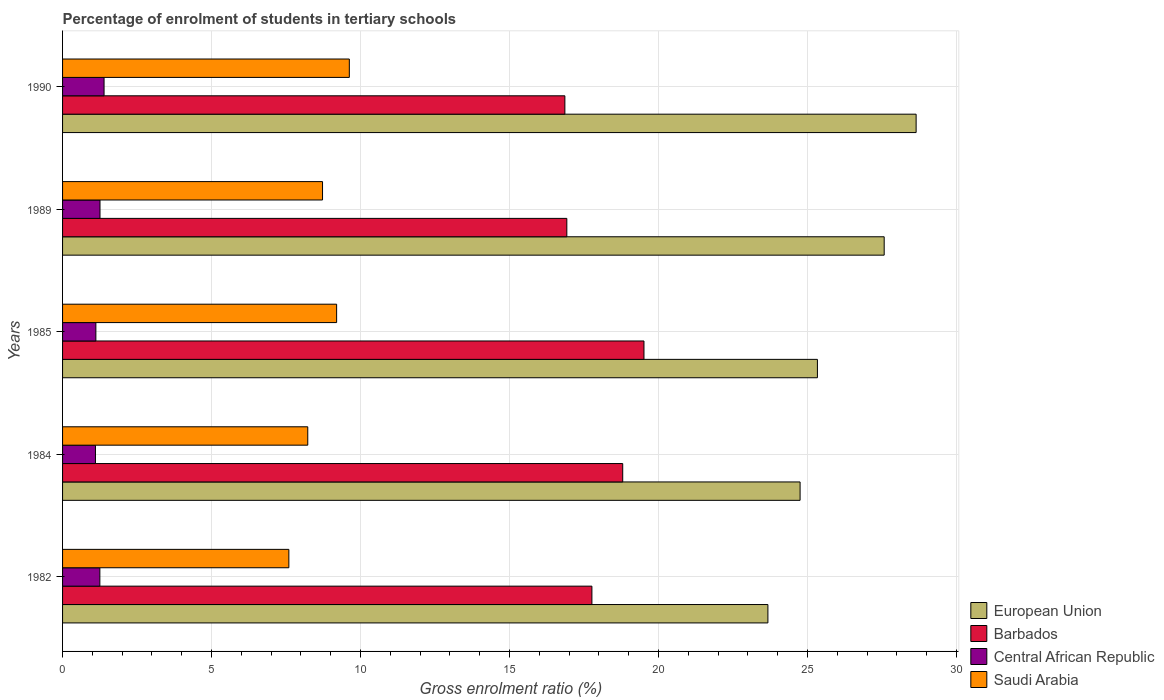How many different coloured bars are there?
Provide a short and direct response. 4. How many groups of bars are there?
Provide a short and direct response. 5. What is the label of the 3rd group of bars from the top?
Provide a short and direct response. 1985. In how many cases, is the number of bars for a given year not equal to the number of legend labels?
Provide a succinct answer. 0. What is the percentage of students enrolled in tertiary schools in Barbados in 1989?
Offer a terse response. 16.92. Across all years, what is the maximum percentage of students enrolled in tertiary schools in Central African Republic?
Your response must be concise. 1.39. Across all years, what is the minimum percentage of students enrolled in tertiary schools in Barbados?
Make the answer very short. 16.86. In which year was the percentage of students enrolled in tertiary schools in Barbados minimum?
Provide a short and direct response. 1990. What is the total percentage of students enrolled in tertiary schools in Barbados in the graph?
Your response must be concise. 89.85. What is the difference between the percentage of students enrolled in tertiary schools in Barbados in 1984 and that in 1990?
Your answer should be very brief. 1.94. What is the difference between the percentage of students enrolled in tertiary schools in Central African Republic in 1985 and the percentage of students enrolled in tertiary schools in Barbados in 1982?
Your response must be concise. -16.65. What is the average percentage of students enrolled in tertiary schools in Central African Republic per year?
Give a very brief answer. 1.22. In the year 1990, what is the difference between the percentage of students enrolled in tertiary schools in Central African Republic and percentage of students enrolled in tertiary schools in Barbados?
Offer a very short reply. -15.46. In how many years, is the percentage of students enrolled in tertiary schools in European Union greater than 20 %?
Provide a succinct answer. 5. What is the ratio of the percentage of students enrolled in tertiary schools in Saudi Arabia in 1984 to that in 1990?
Offer a very short reply. 0.86. Is the difference between the percentage of students enrolled in tertiary schools in Central African Republic in 1982 and 1989 greater than the difference between the percentage of students enrolled in tertiary schools in Barbados in 1982 and 1989?
Provide a short and direct response. No. What is the difference between the highest and the second highest percentage of students enrolled in tertiary schools in Central African Republic?
Your answer should be compact. 0.14. What is the difference between the highest and the lowest percentage of students enrolled in tertiary schools in Barbados?
Your response must be concise. 2.65. Is it the case that in every year, the sum of the percentage of students enrolled in tertiary schools in Central African Republic and percentage of students enrolled in tertiary schools in Saudi Arabia is greater than the sum of percentage of students enrolled in tertiary schools in European Union and percentage of students enrolled in tertiary schools in Barbados?
Your answer should be compact. No. What does the 2nd bar from the top in 1984 represents?
Ensure brevity in your answer.  Central African Republic. What does the 4th bar from the bottom in 1990 represents?
Provide a succinct answer. Saudi Arabia. Is it the case that in every year, the sum of the percentage of students enrolled in tertiary schools in Saudi Arabia and percentage of students enrolled in tertiary schools in Barbados is greater than the percentage of students enrolled in tertiary schools in European Union?
Your response must be concise. No. How many bars are there?
Keep it short and to the point. 20. Are all the bars in the graph horizontal?
Give a very brief answer. Yes. Does the graph contain any zero values?
Your response must be concise. No. Does the graph contain grids?
Give a very brief answer. Yes. Where does the legend appear in the graph?
Give a very brief answer. Bottom right. How are the legend labels stacked?
Provide a short and direct response. Vertical. What is the title of the graph?
Keep it short and to the point. Percentage of enrolment of students in tertiary schools. What is the Gross enrolment ratio (%) in European Union in 1982?
Offer a very short reply. 23.67. What is the Gross enrolment ratio (%) in Barbados in 1982?
Keep it short and to the point. 17.76. What is the Gross enrolment ratio (%) in Central African Republic in 1982?
Ensure brevity in your answer.  1.25. What is the Gross enrolment ratio (%) of Saudi Arabia in 1982?
Make the answer very short. 7.59. What is the Gross enrolment ratio (%) in European Union in 1984?
Provide a short and direct response. 24.75. What is the Gross enrolment ratio (%) in Barbados in 1984?
Your response must be concise. 18.8. What is the Gross enrolment ratio (%) in Central African Republic in 1984?
Your response must be concise. 1.1. What is the Gross enrolment ratio (%) in Saudi Arabia in 1984?
Provide a short and direct response. 8.23. What is the Gross enrolment ratio (%) in European Union in 1985?
Offer a very short reply. 25.33. What is the Gross enrolment ratio (%) of Barbados in 1985?
Your response must be concise. 19.51. What is the Gross enrolment ratio (%) of Central African Republic in 1985?
Your answer should be very brief. 1.12. What is the Gross enrolment ratio (%) of Saudi Arabia in 1985?
Offer a very short reply. 9.2. What is the Gross enrolment ratio (%) in European Union in 1989?
Provide a succinct answer. 27.57. What is the Gross enrolment ratio (%) of Barbados in 1989?
Keep it short and to the point. 16.92. What is the Gross enrolment ratio (%) in Central African Republic in 1989?
Ensure brevity in your answer.  1.26. What is the Gross enrolment ratio (%) in Saudi Arabia in 1989?
Your answer should be compact. 8.72. What is the Gross enrolment ratio (%) of European Union in 1990?
Make the answer very short. 28.64. What is the Gross enrolment ratio (%) of Barbados in 1990?
Your response must be concise. 16.86. What is the Gross enrolment ratio (%) of Central African Republic in 1990?
Provide a short and direct response. 1.39. What is the Gross enrolment ratio (%) of Saudi Arabia in 1990?
Give a very brief answer. 9.62. Across all years, what is the maximum Gross enrolment ratio (%) of European Union?
Make the answer very short. 28.64. Across all years, what is the maximum Gross enrolment ratio (%) of Barbados?
Offer a very short reply. 19.51. Across all years, what is the maximum Gross enrolment ratio (%) of Central African Republic?
Keep it short and to the point. 1.39. Across all years, what is the maximum Gross enrolment ratio (%) in Saudi Arabia?
Provide a short and direct response. 9.62. Across all years, what is the minimum Gross enrolment ratio (%) of European Union?
Make the answer very short. 23.67. Across all years, what is the minimum Gross enrolment ratio (%) in Barbados?
Ensure brevity in your answer.  16.86. Across all years, what is the minimum Gross enrolment ratio (%) of Central African Republic?
Offer a terse response. 1.1. Across all years, what is the minimum Gross enrolment ratio (%) of Saudi Arabia?
Provide a succinct answer. 7.59. What is the total Gross enrolment ratio (%) of European Union in the graph?
Keep it short and to the point. 129.96. What is the total Gross enrolment ratio (%) in Barbados in the graph?
Your response must be concise. 89.85. What is the total Gross enrolment ratio (%) of Central African Republic in the graph?
Provide a short and direct response. 6.12. What is the total Gross enrolment ratio (%) in Saudi Arabia in the graph?
Ensure brevity in your answer.  43.37. What is the difference between the Gross enrolment ratio (%) of European Union in 1982 and that in 1984?
Ensure brevity in your answer.  -1.08. What is the difference between the Gross enrolment ratio (%) of Barbados in 1982 and that in 1984?
Give a very brief answer. -1.03. What is the difference between the Gross enrolment ratio (%) of Central African Republic in 1982 and that in 1984?
Keep it short and to the point. 0.15. What is the difference between the Gross enrolment ratio (%) in Saudi Arabia in 1982 and that in 1984?
Offer a terse response. -0.63. What is the difference between the Gross enrolment ratio (%) in European Union in 1982 and that in 1985?
Keep it short and to the point. -1.66. What is the difference between the Gross enrolment ratio (%) of Barbados in 1982 and that in 1985?
Offer a terse response. -1.75. What is the difference between the Gross enrolment ratio (%) in Central African Republic in 1982 and that in 1985?
Provide a short and direct response. 0.13. What is the difference between the Gross enrolment ratio (%) of Saudi Arabia in 1982 and that in 1985?
Offer a terse response. -1.6. What is the difference between the Gross enrolment ratio (%) of European Union in 1982 and that in 1989?
Give a very brief answer. -3.9. What is the difference between the Gross enrolment ratio (%) in Barbados in 1982 and that in 1989?
Your answer should be very brief. 0.84. What is the difference between the Gross enrolment ratio (%) of Central African Republic in 1982 and that in 1989?
Your answer should be compact. -0. What is the difference between the Gross enrolment ratio (%) in Saudi Arabia in 1982 and that in 1989?
Ensure brevity in your answer.  -1.13. What is the difference between the Gross enrolment ratio (%) of European Union in 1982 and that in 1990?
Provide a short and direct response. -4.97. What is the difference between the Gross enrolment ratio (%) in Barbados in 1982 and that in 1990?
Provide a succinct answer. 0.91. What is the difference between the Gross enrolment ratio (%) of Central African Republic in 1982 and that in 1990?
Ensure brevity in your answer.  -0.14. What is the difference between the Gross enrolment ratio (%) of Saudi Arabia in 1982 and that in 1990?
Ensure brevity in your answer.  -2.03. What is the difference between the Gross enrolment ratio (%) of European Union in 1984 and that in 1985?
Provide a short and direct response. -0.58. What is the difference between the Gross enrolment ratio (%) in Barbados in 1984 and that in 1985?
Your answer should be compact. -0.71. What is the difference between the Gross enrolment ratio (%) in Central African Republic in 1984 and that in 1985?
Your answer should be compact. -0.01. What is the difference between the Gross enrolment ratio (%) in Saudi Arabia in 1984 and that in 1985?
Keep it short and to the point. -0.97. What is the difference between the Gross enrolment ratio (%) in European Union in 1984 and that in 1989?
Ensure brevity in your answer.  -2.82. What is the difference between the Gross enrolment ratio (%) in Barbados in 1984 and that in 1989?
Keep it short and to the point. 1.88. What is the difference between the Gross enrolment ratio (%) of Central African Republic in 1984 and that in 1989?
Ensure brevity in your answer.  -0.15. What is the difference between the Gross enrolment ratio (%) of Saudi Arabia in 1984 and that in 1989?
Provide a short and direct response. -0.5. What is the difference between the Gross enrolment ratio (%) in European Union in 1984 and that in 1990?
Make the answer very short. -3.89. What is the difference between the Gross enrolment ratio (%) in Barbados in 1984 and that in 1990?
Offer a very short reply. 1.94. What is the difference between the Gross enrolment ratio (%) in Central African Republic in 1984 and that in 1990?
Provide a succinct answer. -0.29. What is the difference between the Gross enrolment ratio (%) in Saudi Arabia in 1984 and that in 1990?
Offer a very short reply. -1.39. What is the difference between the Gross enrolment ratio (%) of European Union in 1985 and that in 1989?
Provide a short and direct response. -2.24. What is the difference between the Gross enrolment ratio (%) of Barbados in 1985 and that in 1989?
Your answer should be very brief. 2.59. What is the difference between the Gross enrolment ratio (%) of Central African Republic in 1985 and that in 1989?
Offer a terse response. -0.14. What is the difference between the Gross enrolment ratio (%) in Saudi Arabia in 1985 and that in 1989?
Your answer should be very brief. 0.47. What is the difference between the Gross enrolment ratio (%) in European Union in 1985 and that in 1990?
Give a very brief answer. -3.31. What is the difference between the Gross enrolment ratio (%) of Barbados in 1985 and that in 1990?
Ensure brevity in your answer.  2.65. What is the difference between the Gross enrolment ratio (%) of Central African Republic in 1985 and that in 1990?
Make the answer very short. -0.28. What is the difference between the Gross enrolment ratio (%) of Saudi Arabia in 1985 and that in 1990?
Make the answer very short. -0.43. What is the difference between the Gross enrolment ratio (%) of European Union in 1989 and that in 1990?
Make the answer very short. -1.07. What is the difference between the Gross enrolment ratio (%) in Barbados in 1989 and that in 1990?
Your response must be concise. 0.07. What is the difference between the Gross enrolment ratio (%) of Central African Republic in 1989 and that in 1990?
Provide a short and direct response. -0.14. What is the difference between the Gross enrolment ratio (%) in Saudi Arabia in 1989 and that in 1990?
Provide a succinct answer. -0.9. What is the difference between the Gross enrolment ratio (%) of European Union in 1982 and the Gross enrolment ratio (%) of Barbados in 1984?
Your answer should be compact. 4.87. What is the difference between the Gross enrolment ratio (%) in European Union in 1982 and the Gross enrolment ratio (%) in Central African Republic in 1984?
Your answer should be very brief. 22.56. What is the difference between the Gross enrolment ratio (%) of European Union in 1982 and the Gross enrolment ratio (%) of Saudi Arabia in 1984?
Your answer should be very brief. 15.44. What is the difference between the Gross enrolment ratio (%) of Barbados in 1982 and the Gross enrolment ratio (%) of Central African Republic in 1984?
Your answer should be compact. 16.66. What is the difference between the Gross enrolment ratio (%) in Barbados in 1982 and the Gross enrolment ratio (%) in Saudi Arabia in 1984?
Offer a terse response. 9.53. What is the difference between the Gross enrolment ratio (%) of Central African Republic in 1982 and the Gross enrolment ratio (%) of Saudi Arabia in 1984?
Provide a succinct answer. -6.98. What is the difference between the Gross enrolment ratio (%) of European Union in 1982 and the Gross enrolment ratio (%) of Barbados in 1985?
Give a very brief answer. 4.16. What is the difference between the Gross enrolment ratio (%) of European Union in 1982 and the Gross enrolment ratio (%) of Central African Republic in 1985?
Offer a terse response. 22.55. What is the difference between the Gross enrolment ratio (%) in European Union in 1982 and the Gross enrolment ratio (%) in Saudi Arabia in 1985?
Offer a very short reply. 14.47. What is the difference between the Gross enrolment ratio (%) in Barbados in 1982 and the Gross enrolment ratio (%) in Central African Republic in 1985?
Offer a very short reply. 16.65. What is the difference between the Gross enrolment ratio (%) of Barbados in 1982 and the Gross enrolment ratio (%) of Saudi Arabia in 1985?
Ensure brevity in your answer.  8.57. What is the difference between the Gross enrolment ratio (%) of Central African Republic in 1982 and the Gross enrolment ratio (%) of Saudi Arabia in 1985?
Keep it short and to the point. -7.95. What is the difference between the Gross enrolment ratio (%) in European Union in 1982 and the Gross enrolment ratio (%) in Barbados in 1989?
Your answer should be compact. 6.75. What is the difference between the Gross enrolment ratio (%) of European Union in 1982 and the Gross enrolment ratio (%) of Central African Republic in 1989?
Your response must be concise. 22.41. What is the difference between the Gross enrolment ratio (%) in European Union in 1982 and the Gross enrolment ratio (%) in Saudi Arabia in 1989?
Ensure brevity in your answer.  14.95. What is the difference between the Gross enrolment ratio (%) of Barbados in 1982 and the Gross enrolment ratio (%) of Central African Republic in 1989?
Offer a very short reply. 16.51. What is the difference between the Gross enrolment ratio (%) in Barbados in 1982 and the Gross enrolment ratio (%) in Saudi Arabia in 1989?
Your response must be concise. 9.04. What is the difference between the Gross enrolment ratio (%) of Central African Republic in 1982 and the Gross enrolment ratio (%) of Saudi Arabia in 1989?
Ensure brevity in your answer.  -7.47. What is the difference between the Gross enrolment ratio (%) in European Union in 1982 and the Gross enrolment ratio (%) in Barbados in 1990?
Your answer should be compact. 6.81. What is the difference between the Gross enrolment ratio (%) in European Union in 1982 and the Gross enrolment ratio (%) in Central African Republic in 1990?
Ensure brevity in your answer.  22.28. What is the difference between the Gross enrolment ratio (%) in European Union in 1982 and the Gross enrolment ratio (%) in Saudi Arabia in 1990?
Provide a succinct answer. 14.05. What is the difference between the Gross enrolment ratio (%) of Barbados in 1982 and the Gross enrolment ratio (%) of Central African Republic in 1990?
Your answer should be very brief. 16.37. What is the difference between the Gross enrolment ratio (%) in Barbados in 1982 and the Gross enrolment ratio (%) in Saudi Arabia in 1990?
Offer a very short reply. 8.14. What is the difference between the Gross enrolment ratio (%) of Central African Republic in 1982 and the Gross enrolment ratio (%) of Saudi Arabia in 1990?
Give a very brief answer. -8.37. What is the difference between the Gross enrolment ratio (%) in European Union in 1984 and the Gross enrolment ratio (%) in Barbados in 1985?
Your answer should be very brief. 5.24. What is the difference between the Gross enrolment ratio (%) of European Union in 1984 and the Gross enrolment ratio (%) of Central African Republic in 1985?
Provide a succinct answer. 23.63. What is the difference between the Gross enrolment ratio (%) of European Union in 1984 and the Gross enrolment ratio (%) of Saudi Arabia in 1985?
Keep it short and to the point. 15.55. What is the difference between the Gross enrolment ratio (%) of Barbados in 1984 and the Gross enrolment ratio (%) of Central African Republic in 1985?
Provide a short and direct response. 17.68. What is the difference between the Gross enrolment ratio (%) in Barbados in 1984 and the Gross enrolment ratio (%) in Saudi Arabia in 1985?
Your answer should be compact. 9.6. What is the difference between the Gross enrolment ratio (%) of Central African Republic in 1984 and the Gross enrolment ratio (%) of Saudi Arabia in 1985?
Offer a very short reply. -8.09. What is the difference between the Gross enrolment ratio (%) of European Union in 1984 and the Gross enrolment ratio (%) of Barbados in 1989?
Give a very brief answer. 7.83. What is the difference between the Gross enrolment ratio (%) of European Union in 1984 and the Gross enrolment ratio (%) of Central African Republic in 1989?
Keep it short and to the point. 23.49. What is the difference between the Gross enrolment ratio (%) of European Union in 1984 and the Gross enrolment ratio (%) of Saudi Arabia in 1989?
Your answer should be very brief. 16.03. What is the difference between the Gross enrolment ratio (%) in Barbados in 1984 and the Gross enrolment ratio (%) in Central African Republic in 1989?
Offer a terse response. 17.54. What is the difference between the Gross enrolment ratio (%) of Barbados in 1984 and the Gross enrolment ratio (%) of Saudi Arabia in 1989?
Your answer should be very brief. 10.07. What is the difference between the Gross enrolment ratio (%) of Central African Republic in 1984 and the Gross enrolment ratio (%) of Saudi Arabia in 1989?
Offer a very short reply. -7.62. What is the difference between the Gross enrolment ratio (%) in European Union in 1984 and the Gross enrolment ratio (%) in Barbados in 1990?
Your answer should be compact. 7.89. What is the difference between the Gross enrolment ratio (%) of European Union in 1984 and the Gross enrolment ratio (%) of Central African Republic in 1990?
Keep it short and to the point. 23.36. What is the difference between the Gross enrolment ratio (%) of European Union in 1984 and the Gross enrolment ratio (%) of Saudi Arabia in 1990?
Your answer should be very brief. 15.13. What is the difference between the Gross enrolment ratio (%) in Barbados in 1984 and the Gross enrolment ratio (%) in Central African Republic in 1990?
Provide a short and direct response. 17.4. What is the difference between the Gross enrolment ratio (%) in Barbados in 1984 and the Gross enrolment ratio (%) in Saudi Arabia in 1990?
Provide a succinct answer. 9.17. What is the difference between the Gross enrolment ratio (%) in Central African Republic in 1984 and the Gross enrolment ratio (%) in Saudi Arabia in 1990?
Keep it short and to the point. -8.52. What is the difference between the Gross enrolment ratio (%) of European Union in 1985 and the Gross enrolment ratio (%) of Barbados in 1989?
Provide a short and direct response. 8.41. What is the difference between the Gross enrolment ratio (%) of European Union in 1985 and the Gross enrolment ratio (%) of Central African Republic in 1989?
Make the answer very short. 24.07. What is the difference between the Gross enrolment ratio (%) in European Union in 1985 and the Gross enrolment ratio (%) in Saudi Arabia in 1989?
Keep it short and to the point. 16.61. What is the difference between the Gross enrolment ratio (%) of Barbados in 1985 and the Gross enrolment ratio (%) of Central African Republic in 1989?
Offer a terse response. 18.25. What is the difference between the Gross enrolment ratio (%) in Barbados in 1985 and the Gross enrolment ratio (%) in Saudi Arabia in 1989?
Keep it short and to the point. 10.79. What is the difference between the Gross enrolment ratio (%) in Central African Republic in 1985 and the Gross enrolment ratio (%) in Saudi Arabia in 1989?
Your response must be concise. -7.61. What is the difference between the Gross enrolment ratio (%) in European Union in 1985 and the Gross enrolment ratio (%) in Barbados in 1990?
Give a very brief answer. 8.47. What is the difference between the Gross enrolment ratio (%) in European Union in 1985 and the Gross enrolment ratio (%) in Central African Republic in 1990?
Your answer should be very brief. 23.94. What is the difference between the Gross enrolment ratio (%) of European Union in 1985 and the Gross enrolment ratio (%) of Saudi Arabia in 1990?
Offer a very short reply. 15.71. What is the difference between the Gross enrolment ratio (%) in Barbados in 1985 and the Gross enrolment ratio (%) in Central African Republic in 1990?
Make the answer very short. 18.12. What is the difference between the Gross enrolment ratio (%) in Barbados in 1985 and the Gross enrolment ratio (%) in Saudi Arabia in 1990?
Your answer should be compact. 9.89. What is the difference between the Gross enrolment ratio (%) of Central African Republic in 1985 and the Gross enrolment ratio (%) of Saudi Arabia in 1990?
Your response must be concise. -8.51. What is the difference between the Gross enrolment ratio (%) of European Union in 1989 and the Gross enrolment ratio (%) of Barbados in 1990?
Make the answer very short. 10.72. What is the difference between the Gross enrolment ratio (%) in European Union in 1989 and the Gross enrolment ratio (%) in Central African Republic in 1990?
Ensure brevity in your answer.  26.18. What is the difference between the Gross enrolment ratio (%) of European Union in 1989 and the Gross enrolment ratio (%) of Saudi Arabia in 1990?
Offer a terse response. 17.95. What is the difference between the Gross enrolment ratio (%) of Barbados in 1989 and the Gross enrolment ratio (%) of Central African Republic in 1990?
Your response must be concise. 15.53. What is the difference between the Gross enrolment ratio (%) in Barbados in 1989 and the Gross enrolment ratio (%) in Saudi Arabia in 1990?
Ensure brevity in your answer.  7.3. What is the difference between the Gross enrolment ratio (%) in Central African Republic in 1989 and the Gross enrolment ratio (%) in Saudi Arabia in 1990?
Offer a terse response. -8.37. What is the average Gross enrolment ratio (%) of European Union per year?
Make the answer very short. 25.99. What is the average Gross enrolment ratio (%) of Barbados per year?
Ensure brevity in your answer.  17.97. What is the average Gross enrolment ratio (%) in Central African Republic per year?
Keep it short and to the point. 1.22. What is the average Gross enrolment ratio (%) of Saudi Arabia per year?
Make the answer very short. 8.67. In the year 1982, what is the difference between the Gross enrolment ratio (%) of European Union and Gross enrolment ratio (%) of Barbados?
Offer a very short reply. 5.91. In the year 1982, what is the difference between the Gross enrolment ratio (%) of European Union and Gross enrolment ratio (%) of Central African Republic?
Give a very brief answer. 22.42. In the year 1982, what is the difference between the Gross enrolment ratio (%) of European Union and Gross enrolment ratio (%) of Saudi Arabia?
Give a very brief answer. 16.08. In the year 1982, what is the difference between the Gross enrolment ratio (%) in Barbados and Gross enrolment ratio (%) in Central African Republic?
Ensure brevity in your answer.  16.51. In the year 1982, what is the difference between the Gross enrolment ratio (%) of Barbados and Gross enrolment ratio (%) of Saudi Arabia?
Offer a very short reply. 10.17. In the year 1982, what is the difference between the Gross enrolment ratio (%) in Central African Republic and Gross enrolment ratio (%) in Saudi Arabia?
Keep it short and to the point. -6.34. In the year 1984, what is the difference between the Gross enrolment ratio (%) of European Union and Gross enrolment ratio (%) of Barbados?
Provide a succinct answer. 5.95. In the year 1984, what is the difference between the Gross enrolment ratio (%) in European Union and Gross enrolment ratio (%) in Central African Republic?
Your response must be concise. 23.65. In the year 1984, what is the difference between the Gross enrolment ratio (%) of European Union and Gross enrolment ratio (%) of Saudi Arabia?
Offer a terse response. 16.52. In the year 1984, what is the difference between the Gross enrolment ratio (%) in Barbados and Gross enrolment ratio (%) in Central African Republic?
Provide a short and direct response. 17.69. In the year 1984, what is the difference between the Gross enrolment ratio (%) of Barbados and Gross enrolment ratio (%) of Saudi Arabia?
Provide a short and direct response. 10.57. In the year 1984, what is the difference between the Gross enrolment ratio (%) of Central African Republic and Gross enrolment ratio (%) of Saudi Arabia?
Provide a short and direct response. -7.12. In the year 1985, what is the difference between the Gross enrolment ratio (%) in European Union and Gross enrolment ratio (%) in Barbados?
Offer a terse response. 5.82. In the year 1985, what is the difference between the Gross enrolment ratio (%) of European Union and Gross enrolment ratio (%) of Central African Republic?
Ensure brevity in your answer.  24.21. In the year 1985, what is the difference between the Gross enrolment ratio (%) of European Union and Gross enrolment ratio (%) of Saudi Arabia?
Your answer should be very brief. 16.13. In the year 1985, what is the difference between the Gross enrolment ratio (%) of Barbados and Gross enrolment ratio (%) of Central African Republic?
Your response must be concise. 18.39. In the year 1985, what is the difference between the Gross enrolment ratio (%) of Barbados and Gross enrolment ratio (%) of Saudi Arabia?
Keep it short and to the point. 10.31. In the year 1985, what is the difference between the Gross enrolment ratio (%) of Central African Republic and Gross enrolment ratio (%) of Saudi Arabia?
Provide a short and direct response. -8.08. In the year 1989, what is the difference between the Gross enrolment ratio (%) in European Union and Gross enrolment ratio (%) in Barbados?
Keep it short and to the point. 10.65. In the year 1989, what is the difference between the Gross enrolment ratio (%) of European Union and Gross enrolment ratio (%) of Central African Republic?
Your answer should be very brief. 26.32. In the year 1989, what is the difference between the Gross enrolment ratio (%) in European Union and Gross enrolment ratio (%) in Saudi Arabia?
Your answer should be very brief. 18.85. In the year 1989, what is the difference between the Gross enrolment ratio (%) of Barbados and Gross enrolment ratio (%) of Central African Republic?
Make the answer very short. 15.67. In the year 1989, what is the difference between the Gross enrolment ratio (%) of Barbados and Gross enrolment ratio (%) of Saudi Arabia?
Your answer should be compact. 8.2. In the year 1989, what is the difference between the Gross enrolment ratio (%) in Central African Republic and Gross enrolment ratio (%) in Saudi Arabia?
Make the answer very short. -7.47. In the year 1990, what is the difference between the Gross enrolment ratio (%) of European Union and Gross enrolment ratio (%) of Barbados?
Make the answer very short. 11.79. In the year 1990, what is the difference between the Gross enrolment ratio (%) in European Union and Gross enrolment ratio (%) in Central African Republic?
Offer a terse response. 27.25. In the year 1990, what is the difference between the Gross enrolment ratio (%) of European Union and Gross enrolment ratio (%) of Saudi Arabia?
Offer a very short reply. 19.02. In the year 1990, what is the difference between the Gross enrolment ratio (%) of Barbados and Gross enrolment ratio (%) of Central African Republic?
Your response must be concise. 15.46. In the year 1990, what is the difference between the Gross enrolment ratio (%) of Barbados and Gross enrolment ratio (%) of Saudi Arabia?
Offer a very short reply. 7.23. In the year 1990, what is the difference between the Gross enrolment ratio (%) in Central African Republic and Gross enrolment ratio (%) in Saudi Arabia?
Provide a succinct answer. -8.23. What is the ratio of the Gross enrolment ratio (%) in European Union in 1982 to that in 1984?
Provide a succinct answer. 0.96. What is the ratio of the Gross enrolment ratio (%) of Barbados in 1982 to that in 1984?
Provide a succinct answer. 0.94. What is the ratio of the Gross enrolment ratio (%) of Central African Republic in 1982 to that in 1984?
Offer a terse response. 1.13. What is the ratio of the Gross enrolment ratio (%) of Saudi Arabia in 1982 to that in 1984?
Your response must be concise. 0.92. What is the ratio of the Gross enrolment ratio (%) of European Union in 1982 to that in 1985?
Provide a succinct answer. 0.93. What is the ratio of the Gross enrolment ratio (%) of Barbados in 1982 to that in 1985?
Ensure brevity in your answer.  0.91. What is the ratio of the Gross enrolment ratio (%) in Central African Republic in 1982 to that in 1985?
Provide a short and direct response. 1.12. What is the ratio of the Gross enrolment ratio (%) of Saudi Arabia in 1982 to that in 1985?
Your response must be concise. 0.83. What is the ratio of the Gross enrolment ratio (%) of European Union in 1982 to that in 1989?
Your response must be concise. 0.86. What is the ratio of the Gross enrolment ratio (%) in Barbados in 1982 to that in 1989?
Ensure brevity in your answer.  1.05. What is the ratio of the Gross enrolment ratio (%) in Central African Republic in 1982 to that in 1989?
Give a very brief answer. 1. What is the ratio of the Gross enrolment ratio (%) of Saudi Arabia in 1982 to that in 1989?
Your answer should be very brief. 0.87. What is the ratio of the Gross enrolment ratio (%) of European Union in 1982 to that in 1990?
Offer a terse response. 0.83. What is the ratio of the Gross enrolment ratio (%) of Barbados in 1982 to that in 1990?
Your answer should be very brief. 1.05. What is the ratio of the Gross enrolment ratio (%) in Central African Republic in 1982 to that in 1990?
Your response must be concise. 0.9. What is the ratio of the Gross enrolment ratio (%) in Saudi Arabia in 1982 to that in 1990?
Your response must be concise. 0.79. What is the ratio of the Gross enrolment ratio (%) in Barbados in 1984 to that in 1985?
Offer a very short reply. 0.96. What is the ratio of the Gross enrolment ratio (%) in Central African Republic in 1984 to that in 1985?
Offer a terse response. 0.99. What is the ratio of the Gross enrolment ratio (%) in Saudi Arabia in 1984 to that in 1985?
Your answer should be very brief. 0.89. What is the ratio of the Gross enrolment ratio (%) in European Union in 1984 to that in 1989?
Your answer should be very brief. 0.9. What is the ratio of the Gross enrolment ratio (%) in Barbados in 1984 to that in 1989?
Give a very brief answer. 1.11. What is the ratio of the Gross enrolment ratio (%) in Central African Republic in 1984 to that in 1989?
Your response must be concise. 0.88. What is the ratio of the Gross enrolment ratio (%) of Saudi Arabia in 1984 to that in 1989?
Ensure brevity in your answer.  0.94. What is the ratio of the Gross enrolment ratio (%) in European Union in 1984 to that in 1990?
Provide a succinct answer. 0.86. What is the ratio of the Gross enrolment ratio (%) in Barbados in 1984 to that in 1990?
Offer a terse response. 1.12. What is the ratio of the Gross enrolment ratio (%) in Central African Republic in 1984 to that in 1990?
Your answer should be compact. 0.79. What is the ratio of the Gross enrolment ratio (%) in Saudi Arabia in 1984 to that in 1990?
Make the answer very short. 0.86. What is the ratio of the Gross enrolment ratio (%) in European Union in 1985 to that in 1989?
Ensure brevity in your answer.  0.92. What is the ratio of the Gross enrolment ratio (%) in Barbados in 1985 to that in 1989?
Provide a short and direct response. 1.15. What is the ratio of the Gross enrolment ratio (%) in Central African Republic in 1985 to that in 1989?
Your answer should be very brief. 0.89. What is the ratio of the Gross enrolment ratio (%) of Saudi Arabia in 1985 to that in 1989?
Give a very brief answer. 1.05. What is the ratio of the Gross enrolment ratio (%) of European Union in 1985 to that in 1990?
Keep it short and to the point. 0.88. What is the ratio of the Gross enrolment ratio (%) of Barbados in 1985 to that in 1990?
Keep it short and to the point. 1.16. What is the ratio of the Gross enrolment ratio (%) in Central African Republic in 1985 to that in 1990?
Make the answer very short. 0.8. What is the ratio of the Gross enrolment ratio (%) of Saudi Arabia in 1985 to that in 1990?
Give a very brief answer. 0.96. What is the ratio of the Gross enrolment ratio (%) in European Union in 1989 to that in 1990?
Offer a terse response. 0.96. What is the ratio of the Gross enrolment ratio (%) in Barbados in 1989 to that in 1990?
Your answer should be very brief. 1. What is the ratio of the Gross enrolment ratio (%) of Central African Republic in 1989 to that in 1990?
Provide a short and direct response. 0.9. What is the ratio of the Gross enrolment ratio (%) of Saudi Arabia in 1989 to that in 1990?
Your answer should be very brief. 0.91. What is the difference between the highest and the second highest Gross enrolment ratio (%) of European Union?
Provide a succinct answer. 1.07. What is the difference between the highest and the second highest Gross enrolment ratio (%) in Barbados?
Offer a terse response. 0.71. What is the difference between the highest and the second highest Gross enrolment ratio (%) of Central African Republic?
Offer a very short reply. 0.14. What is the difference between the highest and the second highest Gross enrolment ratio (%) in Saudi Arabia?
Make the answer very short. 0.43. What is the difference between the highest and the lowest Gross enrolment ratio (%) of European Union?
Make the answer very short. 4.97. What is the difference between the highest and the lowest Gross enrolment ratio (%) in Barbados?
Ensure brevity in your answer.  2.65. What is the difference between the highest and the lowest Gross enrolment ratio (%) in Central African Republic?
Provide a succinct answer. 0.29. What is the difference between the highest and the lowest Gross enrolment ratio (%) of Saudi Arabia?
Provide a succinct answer. 2.03. 